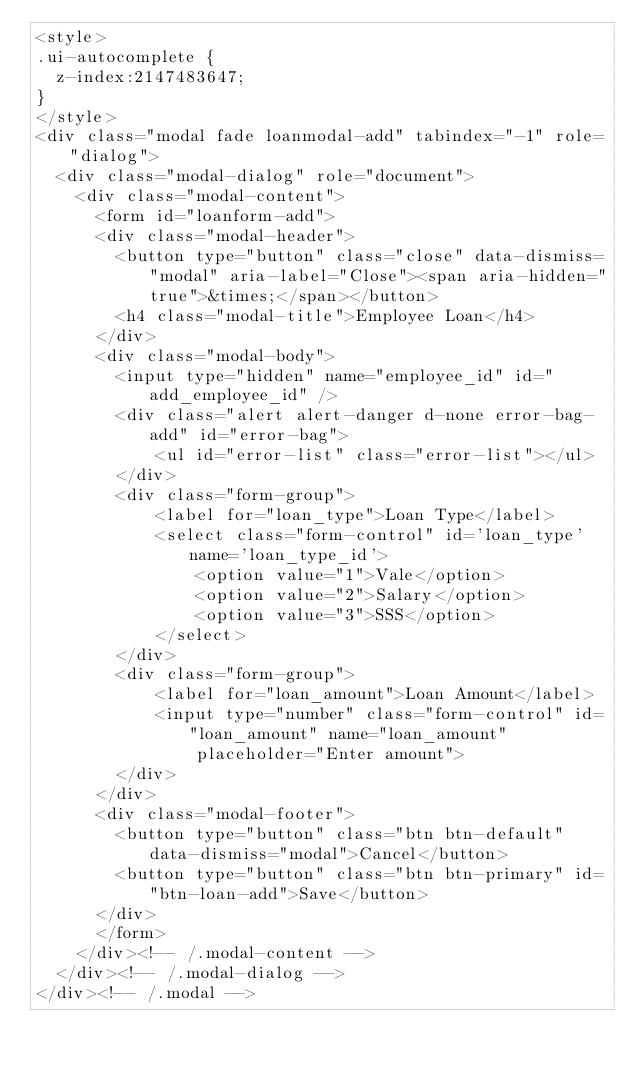<code> <loc_0><loc_0><loc_500><loc_500><_PHP_><style>
.ui-autocomplete {
  z-index:2147483647;
}
</style>
<div class="modal fade loanmodal-add" tabindex="-1" role="dialog">
  <div class="modal-dialog" role="document">
    <div class="modal-content"> 
      <form id="loanform-add">   
      <div class="modal-header">
        <button type="button" class="close" data-dismiss="modal" aria-label="Close"><span aria-hidden="true">&times;</span></button>
        <h4 class="modal-title">Employee Loan</h4>
      </div>
      <div class="modal-body">        
        <input type="hidden" name="employee_id" id="add_employee_id" />
        <div class="alert alert-danger d-none error-bag-add" id="error-bag">
            <ul id="error-list" class="error-list"></ul>
        </div>
        <div class="form-group">
            <label for="loan_type">Loan Type</label>
            <select class="form-control" id='loan_type' name='loan_type_id'>
                <option value="1">Vale</option>
                <option value="2">Salary</option>
                <option value="3">SSS</option>
            </select>
        </div>    
        <div class="form-group">
            <label for="loan_amount">Loan Amount</label>
            <input type="number" class="form-control" id="loan_amount" name="loan_amount" 
                placeholder="Enter amount">
        </div>
      </div>
      <div class="modal-footer">
        <button type="button" class="btn btn-default" data-dismiss="modal">Cancel</button>
        <button type="button" class="btn btn-primary" id="btn-loan-add">Save</button>
      </div>
      </form>
    </div><!-- /.modal-content -->
  </div><!-- /.modal-dialog -->
</div><!-- /.modal -->

</code> 